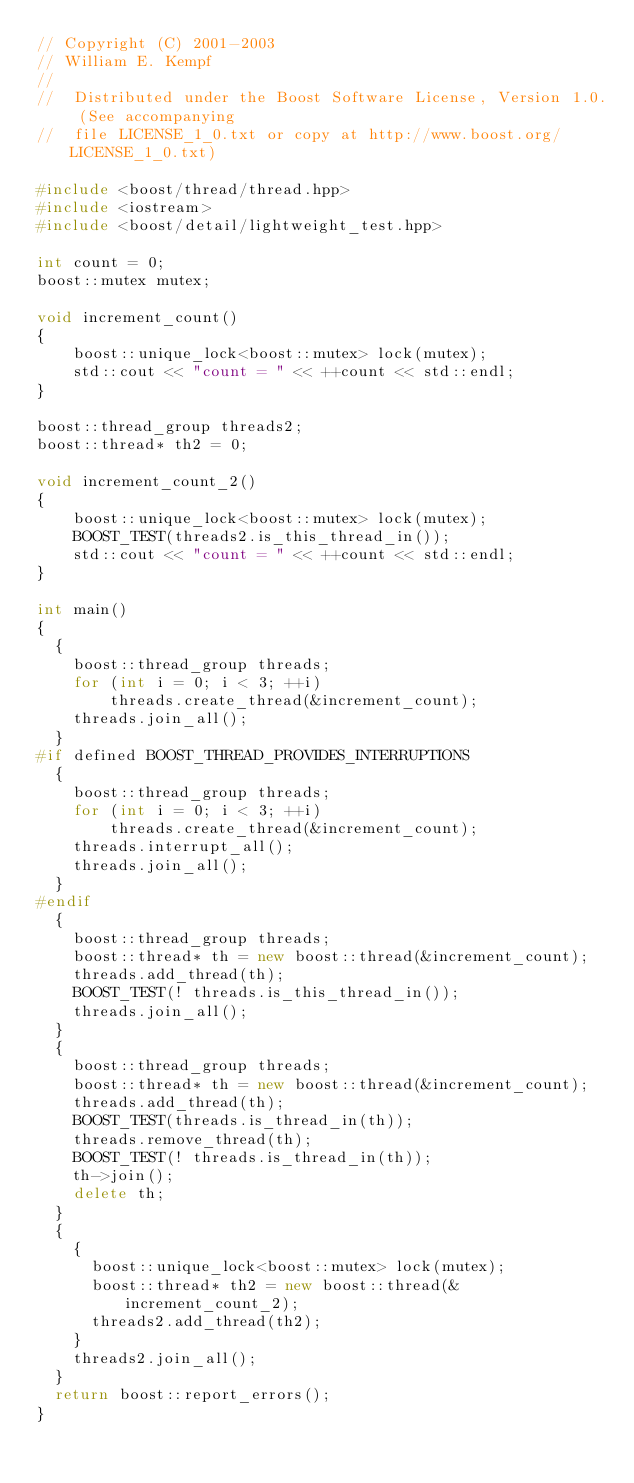Convert code to text. <code><loc_0><loc_0><loc_500><loc_500><_C++_>// Copyright (C) 2001-2003
// William E. Kempf
//
//  Distributed under the Boost Software License, Version 1.0. (See accompanying
//  file LICENSE_1_0.txt or copy at http://www.boost.org/LICENSE_1_0.txt)

#include <boost/thread/thread.hpp>
#include <iostream>
#include <boost/detail/lightweight_test.hpp>

int count = 0;
boost::mutex mutex;

void increment_count()
{
    boost::unique_lock<boost::mutex> lock(mutex);
    std::cout << "count = " << ++count << std::endl;
}

boost::thread_group threads2;
boost::thread* th2 = 0;

void increment_count_2()
{
    boost::unique_lock<boost::mutex> lock(mutex);
    BOOST_TEST(threads2.is_this_thread_in());
    std::cout << "count = " << ++count << std::endl;
}

int main()
{
  {
    boost::thread_group threads;
    for (int i = 0; i < 3; ++i)
        threads.create_thread(&increment_count);
    threads.join_all();
  }
#if defined BOOST_THREAD_PROVIDES_INTERRUPTIONS
  {
    boost::thread_group threads;
    for (int i = 0; i < 3; ++i)
        threads.create_thread(&increment_count);
    threads.interrupt_all();
    threads.join_all();
  }
#endif
  {
    boost::thread_group threads;
    boost::thread* th = new boost::thread(&increment_count);
    threads.add_thread(th);
    BOOST_TEST(! threads.is_this_thread_in());
    threads.join_all();
  }
  {
    boost::thread_group threads;
    boost::thread* th = new boost::thread(&increment_count);
    threads.add_thread(th);
    BOOST_TEST(threads.is_thread_in(th));
    threads.remove_thread(th);
    BOOST_TEST(! threads.is_thread_in(th));
    th->join();
    delete th;
  }
  {
    {
      boost::unique_lock<boost::mutex> lock(mutex);
      boost::thread* th2 = new boost::thread(&increment_count_2);
      threads2.add_thread(th2);
    }
    threads2.join_all();
  }
  return boost::report_errors();
}
</code> 